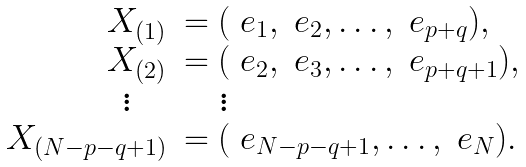<formula> <loc_0><loc_0><loc_500><loc_500>\begin{array} { r l } X _ { ( 1 ) } & = ( \ e _ { 1 } , \ e _ { 2 } , \dots , \ e _ { p + q } ) , \\ X _ { ( 2 ) } & = ( \ e _ { 2 } , \ e _ { 3 } , \dots , \ e _ { p + q + 1 } ) , \\ \vdots \quad & \quad \vdots \\ X _ { ( N - p - q + 1 ) } & = ( \ e _ { N - p - q + 1 } , \dots , \ e _ { N } ) . \end{array}</formula> 